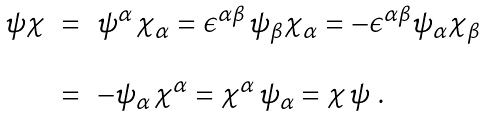<formula> <loc_0><loc_0><loc_500><loc_500>\begin{array} { r c l } \psi \chi & = & \psi ^ { \alpha } \, \chi _ { \alpha } = \epsilon ^ { \alpha \beta } \, \psi _ { \beta } \chi _ { \alpha } = - \epsilon ^ { \alpha \beta } \psi _ { \alpha } \chi _ { \beta } \\ & & \\ & = & - \psi _ { \alpha } \, \chi ^ { \alpha } = \chi ^ { \alpha } \, \psi _ { \alpha } = \chi \, \psi \ . \end{array}</formula> 